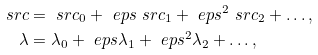<formula> <loc_0><loc_0><loc_500><loc_500>\ s r c & = \ s r c _ { 0 } + \ e p s \ s r c _ { 1 } + \ e p s ^ { 2 } \ s r c _ { 2 } + \dots , \\ \lambda & = \lambda _ { 0 } + \ e p s \lambda _ { 1 } + \ e p s ^ { 2 } \lambda _ { 2 } + \dots ,</formula> 